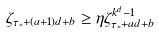<formula> <loc_0><loc_0><loc_500><loc_500>\zeta _ { \tau _ { * } + ( a + 1 ) d + b } \geq \eta \zeta _ { \tau _ { * } + a d + b } ^ { k ^ { d } - 1 }</formula> 